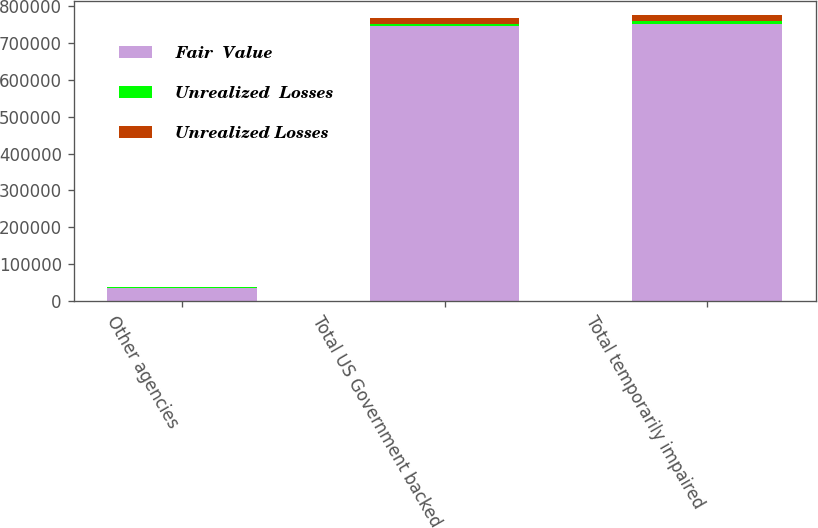<chart> <loc_0><loc_0><loc_500><loc_500><stacked_bar_chart><ecel><fcel>Other agencies<fcel>Total US Government backed<fcel>Total temporarily impaired<nl><fcel>Fair  Value<fcel>36956<fcel>744890<fcel>752484<nl><fcel>Unrealized  Losses<fcel>198<fcel>5748<fcel>6135<nl><fcel>Unrealized Losses<fcel>952<fcel>17138<fcel>17138<nl></chart> 